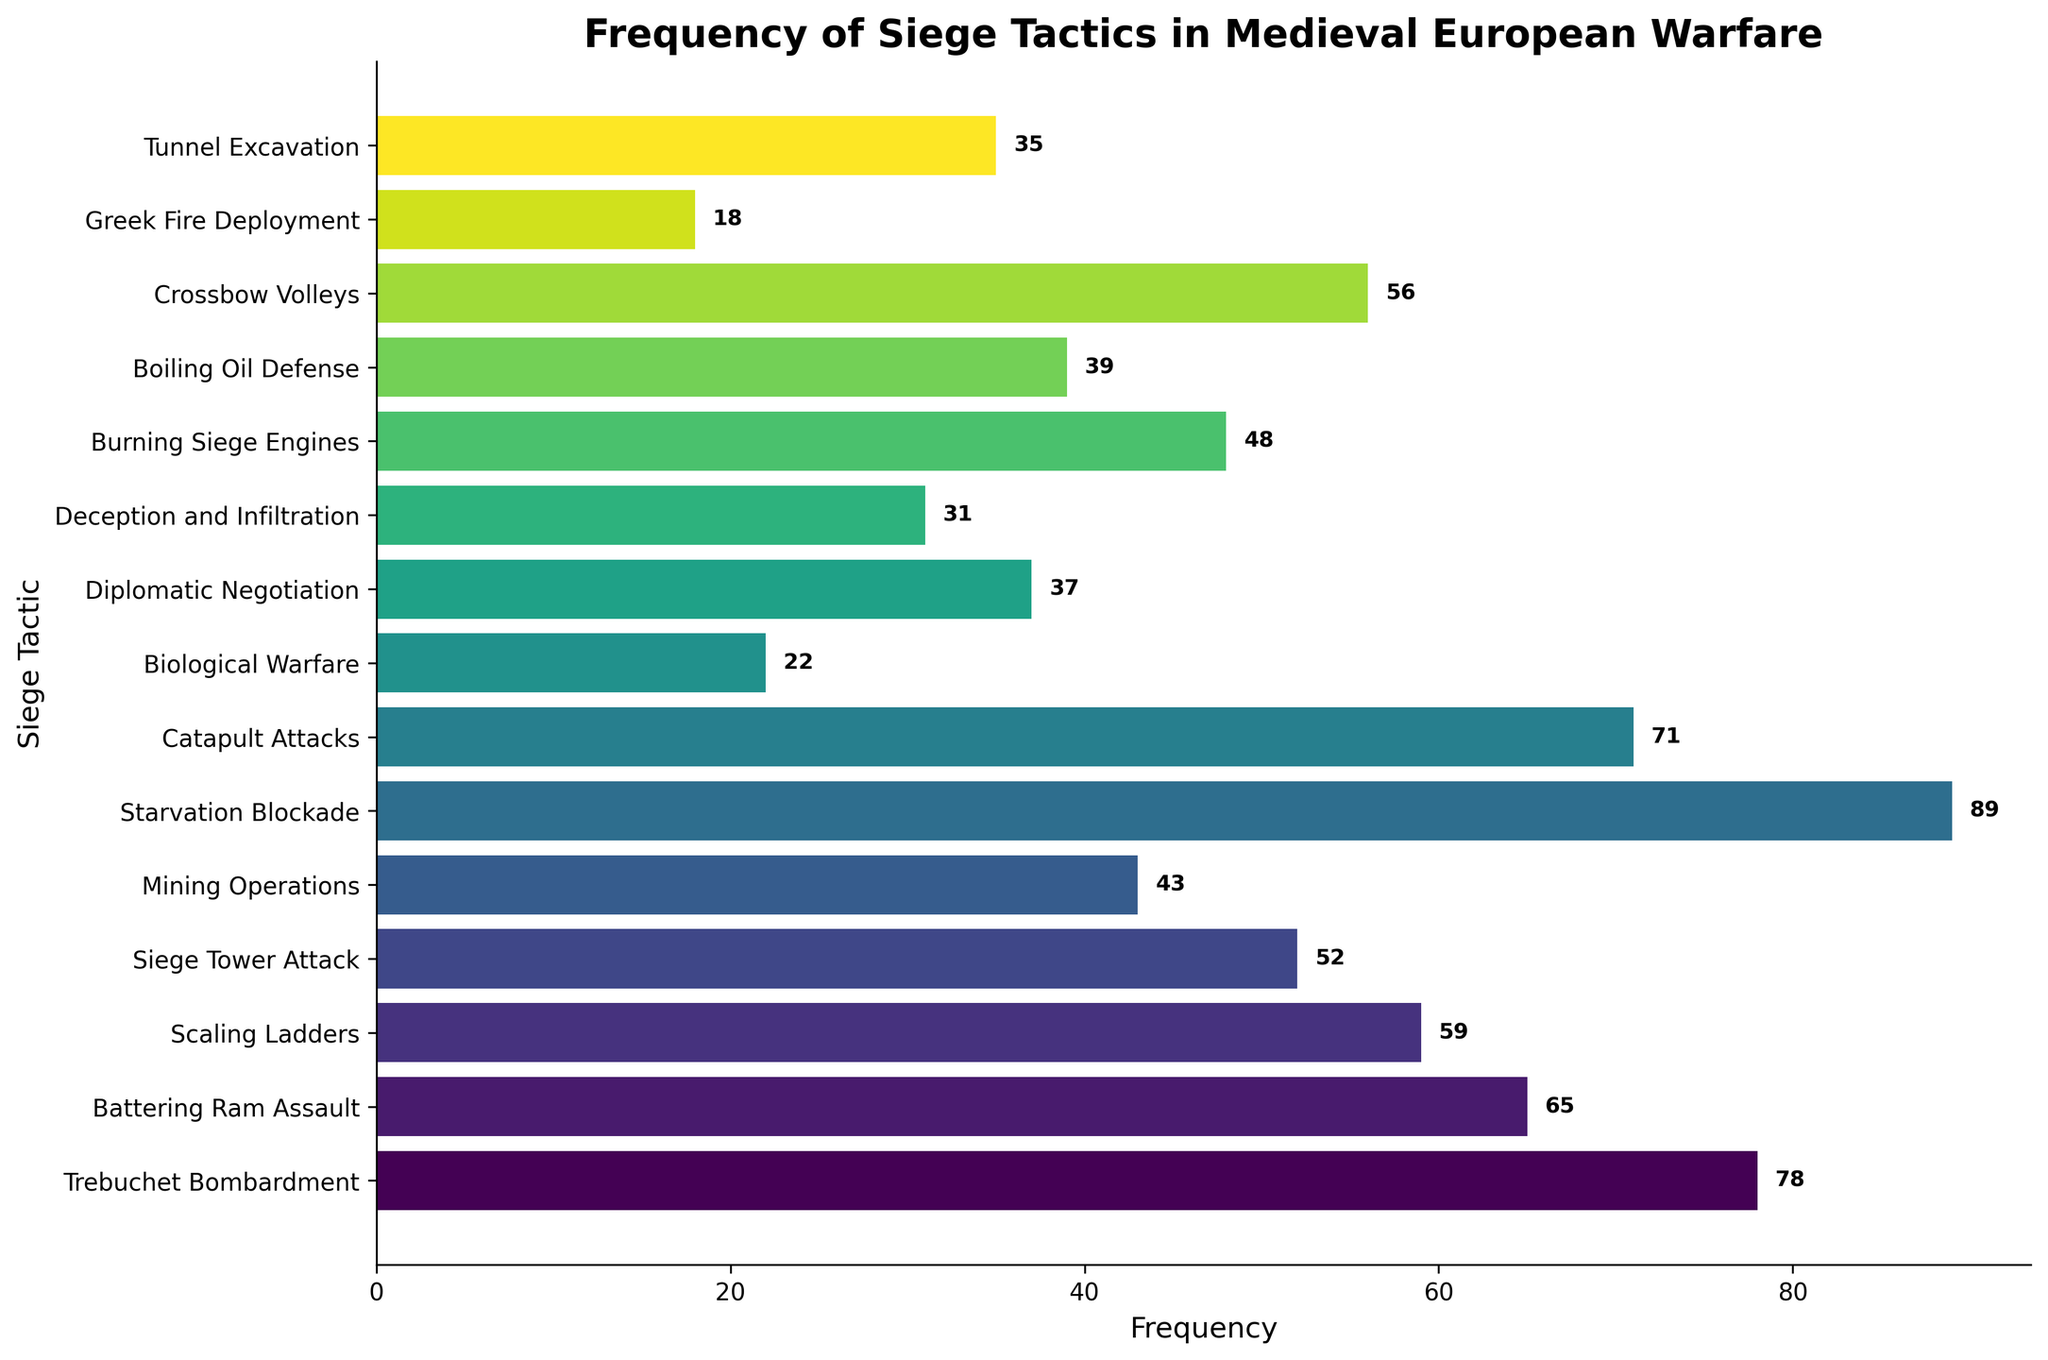What is the most frequently used siege tactic? The most frequently used siege tactic has the highest bar on the chart. Observing the heights of the bars, "Starvation Blockade" is the highest
Answer: Starvation Blockade Which siege tactic was used more frequently: "Battering Ram Assault" or "Scaling Ladders"? Comparing the heights of the bars for "Battering Ram Assault" and "Scaling Ladders", we see that "Battering Ram Assault" is taller. Referring to their frequencies: 65 for "Battering Ram Assault" and 59 for "Scaling Ladders"
Answer: Battering Ram Assault What is the total number of sieges that involved "Mining Operations" and "Tunnel Excavation"? Adding the frequencies for "Mining Operations" (43 sieges) and "Tunnel Excavation" (35 sieges), we get 43 + 35 = 78
Answer: 78 Which tactic is used less frequently: "Diplomatic Negotiation" or "Burning Siege Engines"? Comparing the heights of the bars for "Diplomatic Negotiation" and "Burning Siege Engines", the bar for "Diplomatic Negotiation" is shorter. Referring to their frequencies: 37 for "Diplomatic Negotiation" and 48 for "Burning Siege Engines"
Answer: Diplomatic Negotiation How much more frequent is "Trebuchet Bombardment" compared to "Biological Warfare"? Subtracting the frequency of "Biological Warfare" (22) from "Trebuchet Bombardment" (78), we get 78 - 22 = 56
Answer: 56 What is the sum of the frequencies for "Catapult Attacks" and "Crossbow Volleys"? Adding the frequencies for "Catapult Attacks" (71) and "Crossbow Volleys" (56), we get 71 + 56 = 127
Answer: 127 Which tactics have a frequency higher than 50? By observing the bars taller than the 50 mark, the tactics higher than 50 are: "Trebuchet Bombardment" (78), "Battering Ram Assault" (65), "Scaling Ladders" (59), "Siege Tower Attack" (52), "Starvation Blockade" (89), "Catapult Attacks" (71), and "Crossbow Volleys" (56)
Answer: Trebuchet Bombardment, Battering Ram Assault, Scaling Ladders, Siege Tower Attack, Starvation Blockade, Catapult Attacks, Crossbow Volleys Is "Greek Fire Deployment" used more frequently than "Biological Warfare"? Comparing the heights of the bars for "Greek Fire Deployment" and "Biological Warfare", the bar for "Biological Warfare" is taller. Referring to their frequencies: 18 for "Greek Fire Deployment" and 22 for "Biological Warfare"
Answer: No 